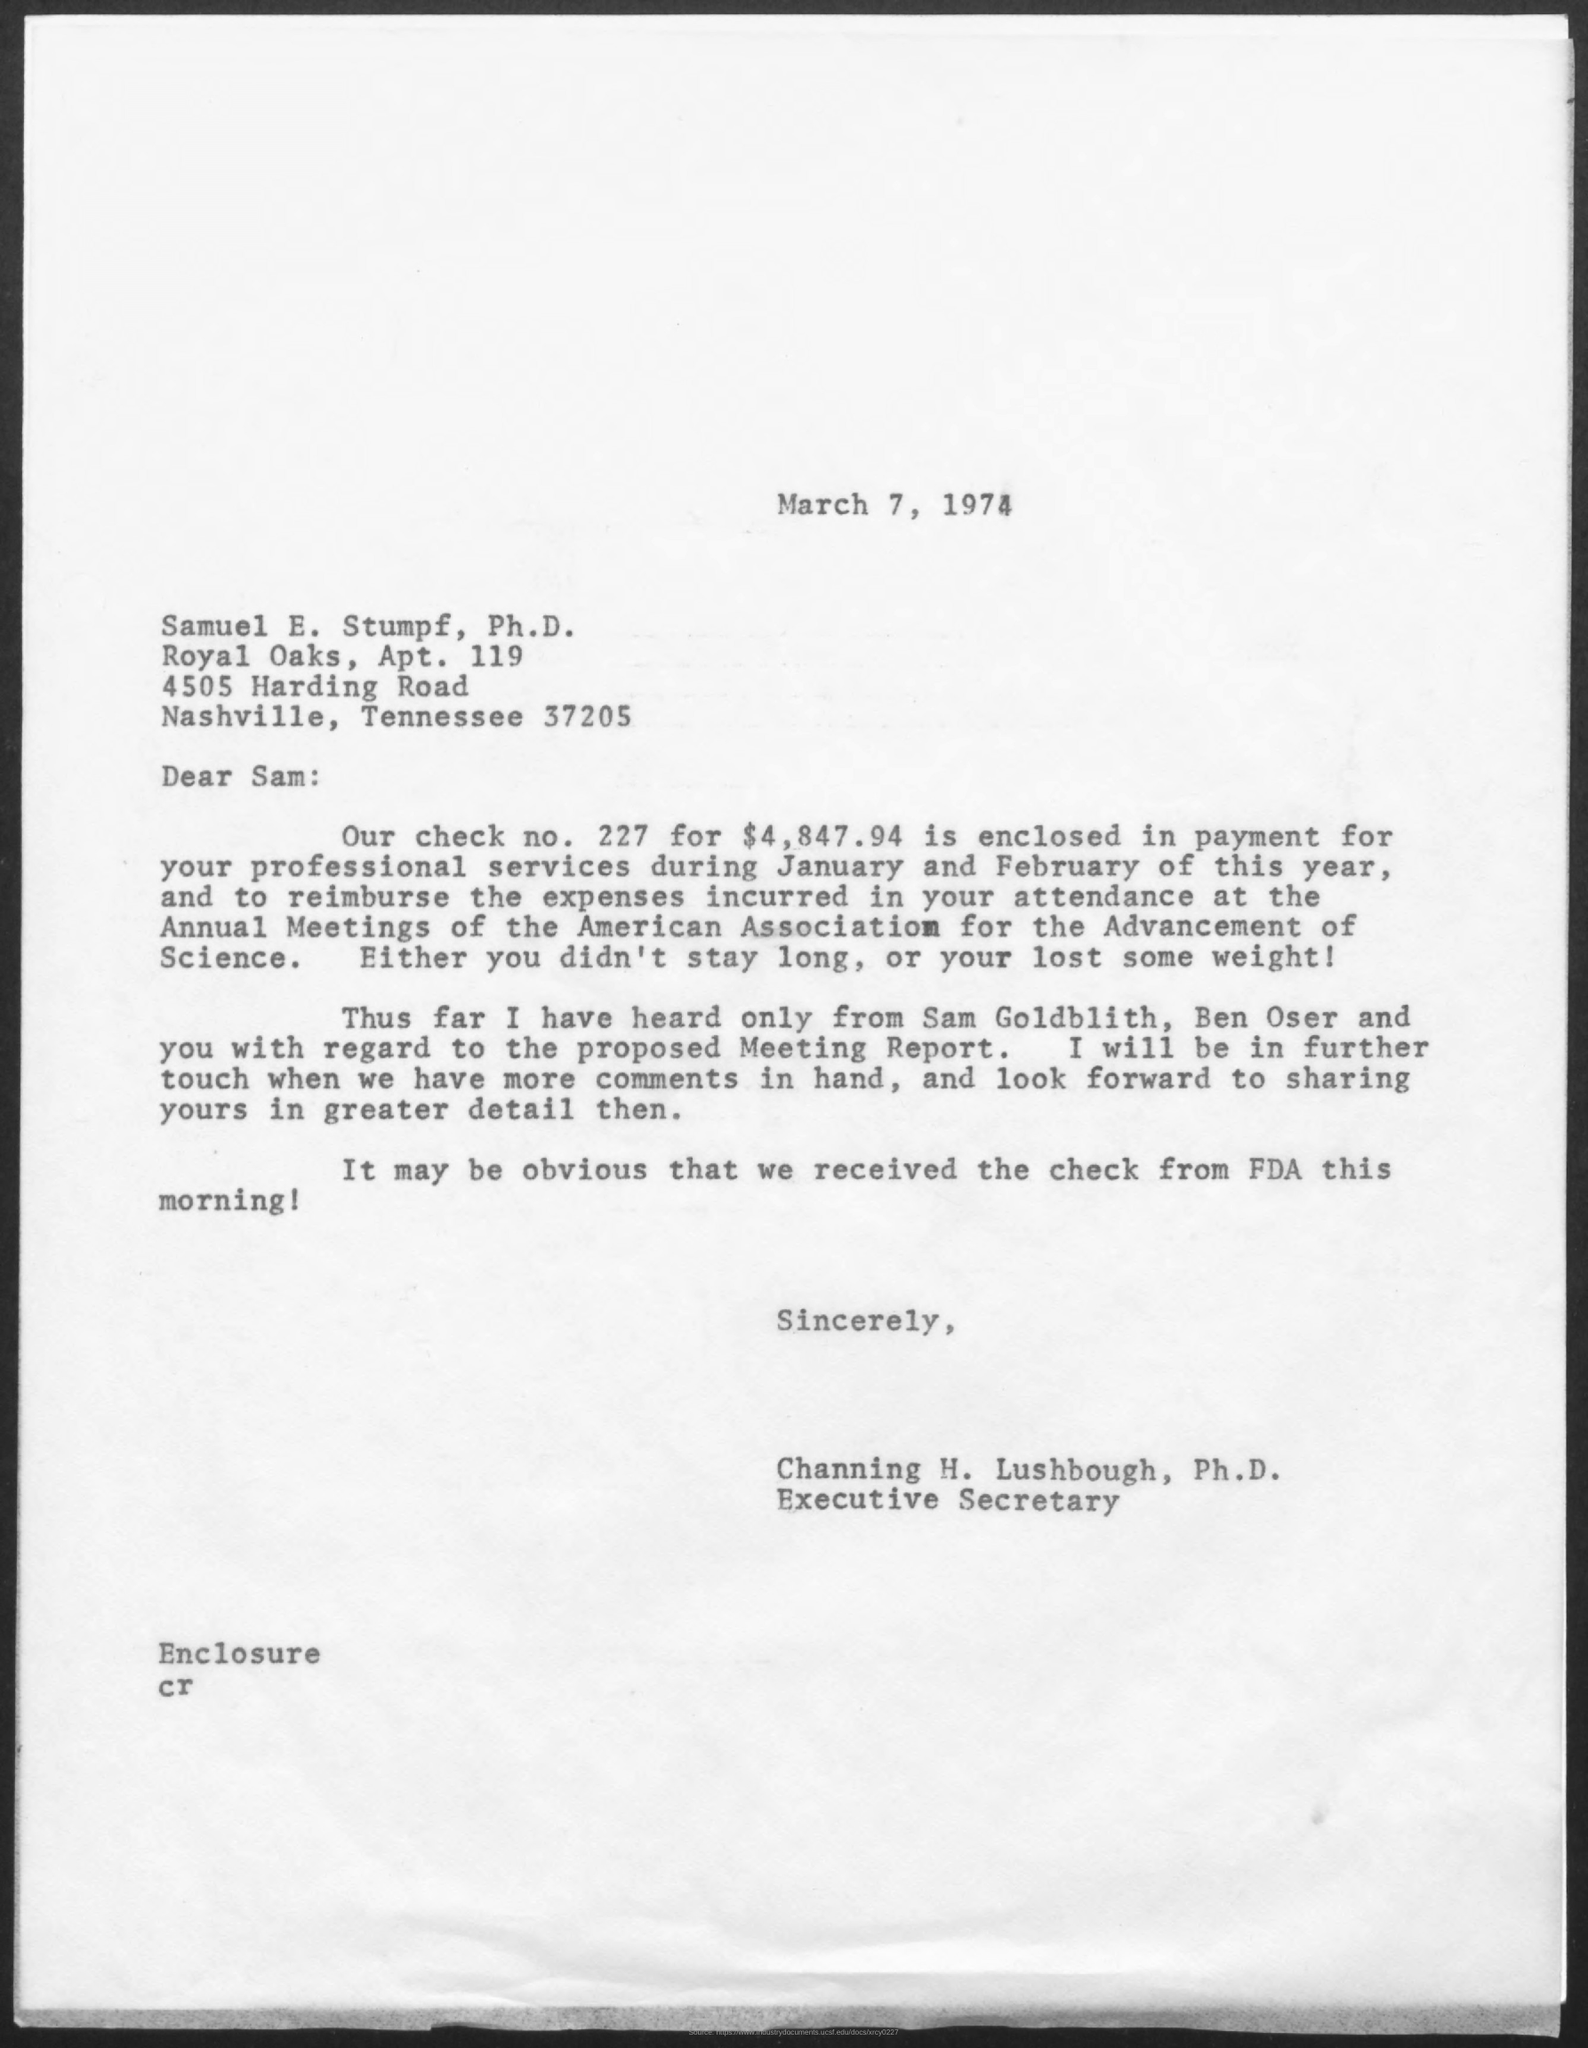What is the date mentioned in this letter?
Provide a short and direct response. March 7, 1974. What is the Check No. given in this letter?
Offer a very short reply. 227. What is the check amount as mentioned in the letter?
Give a very brief answer. $4,847.94. Who is the sender of this letter?
Offer a very short reply. Channing H. Lushbough, Ph.D. 